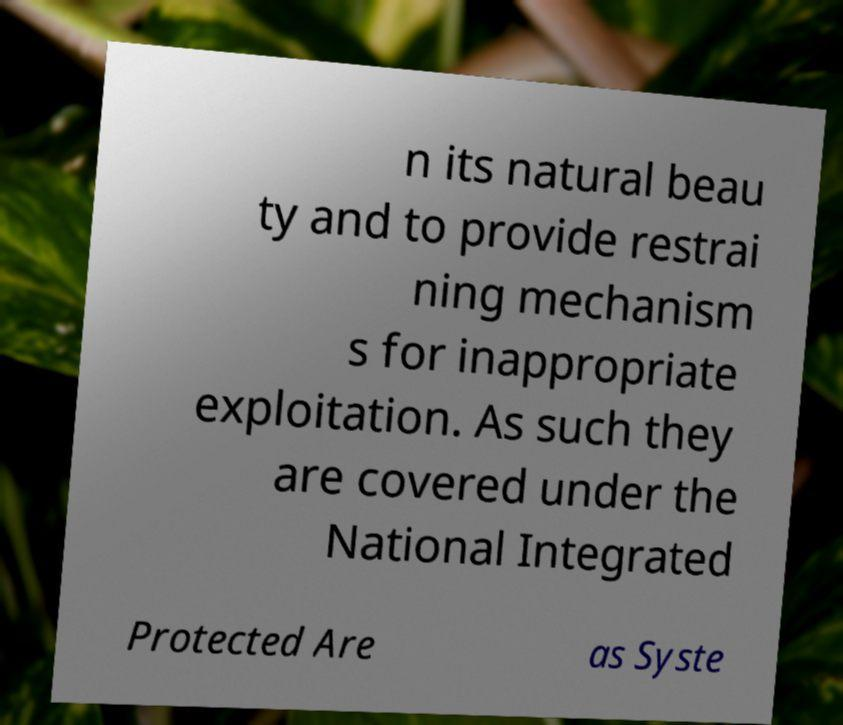Could you extract and type out the text from this image? n its natural beau ty and to provide restrai ning mechanism s for inappropriate exploitation. As such they are covered under the National Integrated Protected Are as Syste 